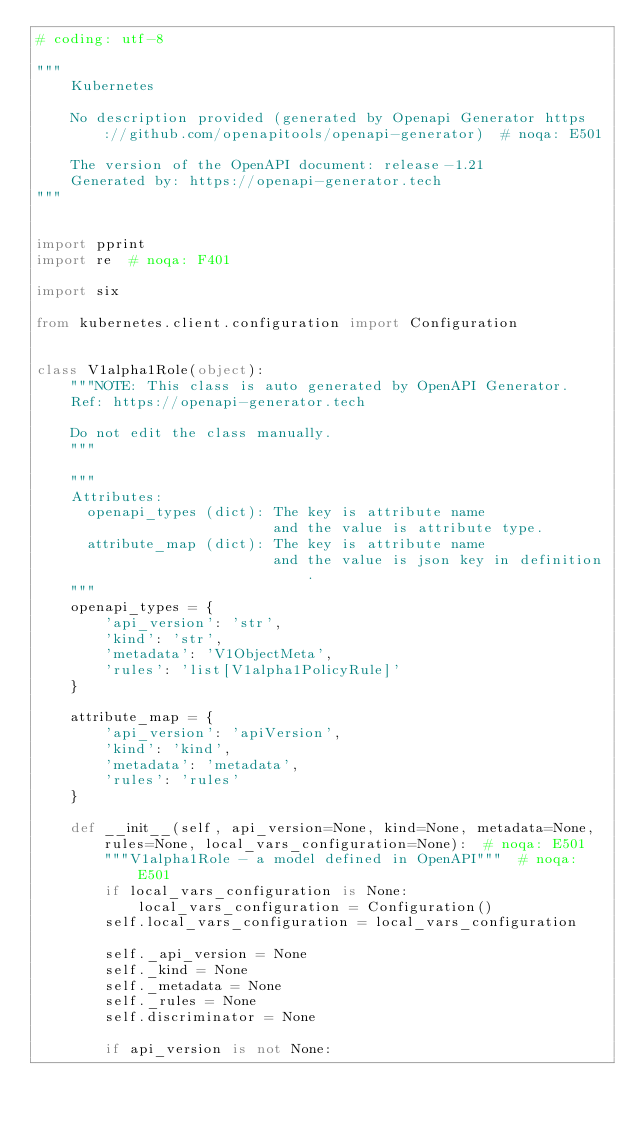<code> <loc_0><loc_0><loc_500><loc_500><_Python_># coding: utf-8

"""
    Kubernetes

    No description provided (generated by Openapi Generator https://github.com/openapitools/openapi-generator)  # noqa: E501

    The version of the OpenAPI document: release-1.21
    Generated by: https://openapi-generator.tech
"""


import pprint
import re  # noqa: F401

import six

from kubernetes.client.configuration import Configuration


class V1alpha1Role(object):
    """NOTE: This class is auto generated by OpenAPI Generator.
    Ref: https://openapi-generator.tech

    Do not edit the class manually.
    """

    """
    Attributes:
      openapi_types (dict): The key is attribute name
                            and the value is attribute type.
      attribute_map (dict): The key is attribute name
                            and the value is json key in definition.
    """
    openapi_types = {
        'api_version': 'str',
        'kind': 'str',
        'metadata': 'V1ObjectMeta',
        'rules': 'list[V1alpha1PolicyRule]'
    }

    attribute_map = {
        'api_version': 'apiVersion',
        'kind': 'kind',
        'metadata': 'metadata',
        'rules': 'rules'
    }

    def __init__(self, api_version=None, kind=None, metadata=None, rules=None, local_vars_configuration=None):  # noqa: E501
        """V1alpha1Role - a model defined in OpenAPI"""  # noqa: E501
        if local_vars_configuration is None:
            local_vars_configuration = Configuration()
        self.local_vars_configuration = local_vars_configuration

        self._api_version = None
        self._kind = None
        self._metadata = None
        self._rules = None
        self.discriminator = None

        if api_version is not None:</code> 